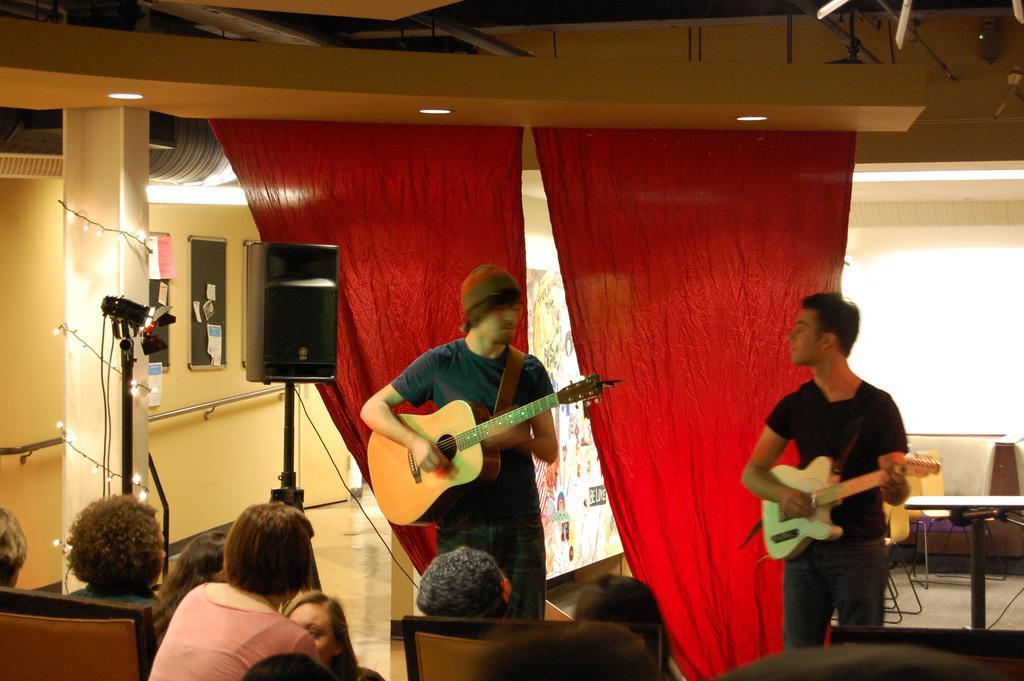How would you summarize this image in a sentence or two? This picture consist of inside view of a building and there is a board on the left side and there is a red color curtain visible on the middle and there are some persons sitting on the chair on the middle and there are two persons holding a guitar on their and wearing a black color shirts and there is a speaker kept on the floor on the middle and there is a pipe line attached to the wall on the left side and there is light visible on the left side corner. 